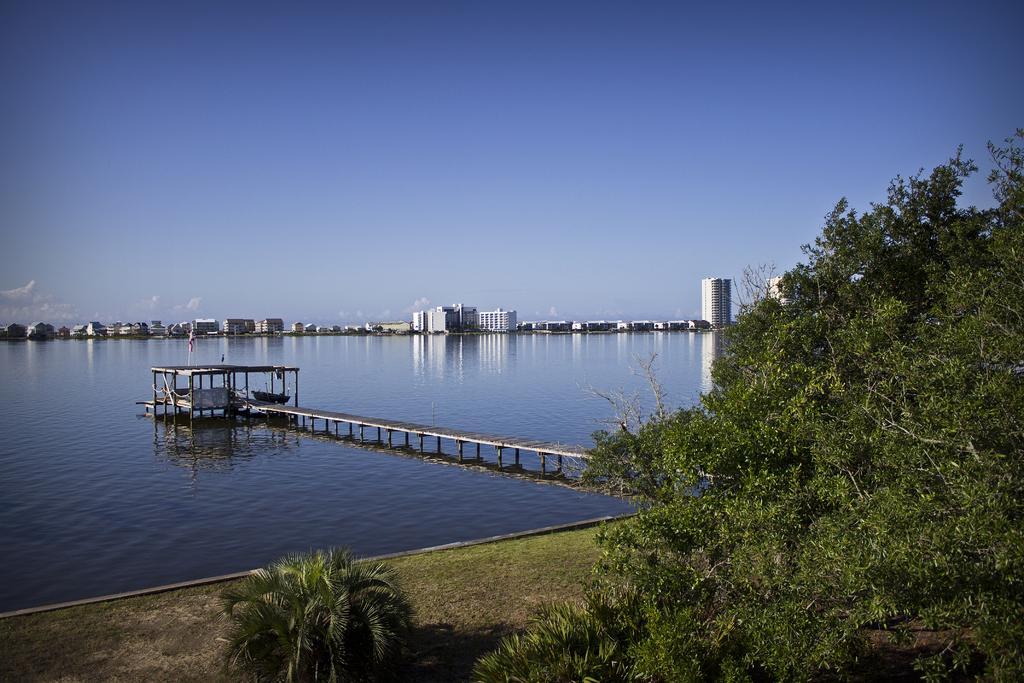In one or two sentences, can you explain what this image depicts? In this image we can see small plants, trees, bridgewater, buildings and sky with clouds in the background. 